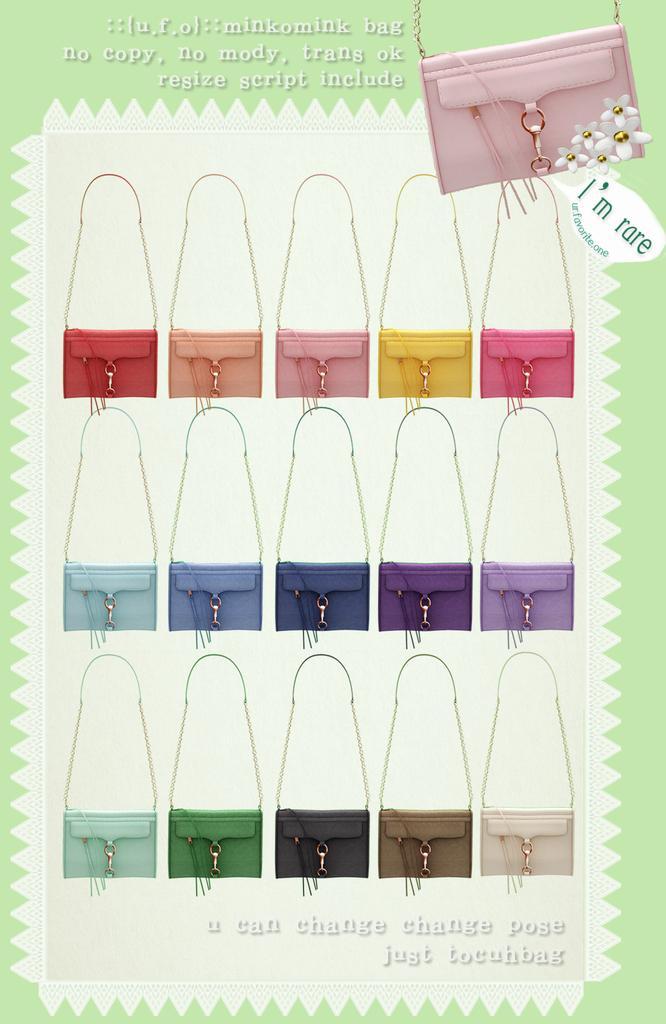How would you summarize this image in a sentence or two? This is an advertisement. In this picture we can see the bags and text. 